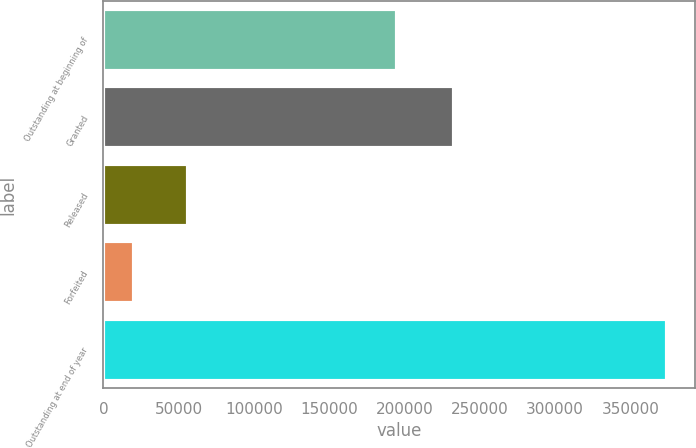Convert chart to OTSL. <chart><loc_0><loc_0><loc_500><loc_500><bar_chart><fcel>Outstanding at beginning of<fcel>Granted<fcel>Released<fcel>Forfeited<fcel>Outstanding at end of year<nl><fcel>195159<fcel>233111<fcel>55917.5<fcel>20555<fcel>374180<nl></chart> 